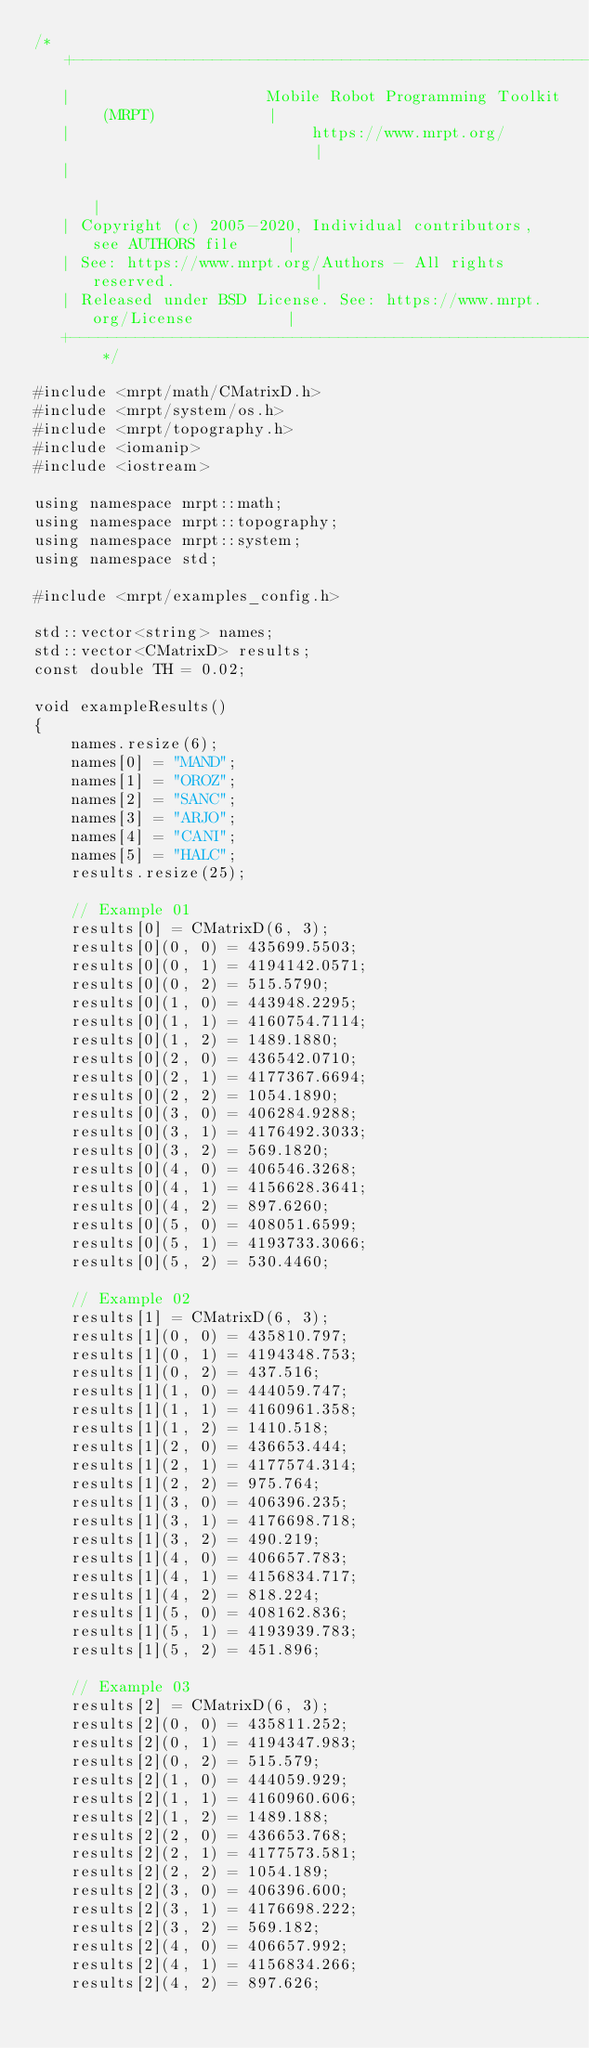<code> <loc_0><loc_0><loc_500><loc_500><_C++_>/* +------------------------------------------------------------------------+
   |                     Mobile Robot Programming Toolkit (MRPT)            |
   |                          https://www.mrpt.org/                         |
   |                                                                        |
   | Copyright (c) 2005-2020, Individual contributors, see AUTHORS file     |
   | See: https://www.mrpt.org/Authors - All rights reserved.               |
   | Released under BSD License. See: https://www.mrpt.org/License          |
   +------------------------------------------------------------------------+ */

#include <mrpt/math/CMatrixD.h>
#include <mrpt/system/os.h>
#include <mrpt/topography.h>
#include <iomanip>
#include <iostream>

using namespace mrpt::math;
using namespace mrpt::topography;
using namespace mrpt::system;
using namespace std;

#include <mrpt/examples_config.h>

std::vector<string> names;
std::vector<CMatrixD> results;
const double TH = 0.02;

void exampleResults()
{
	names.resize(6);
	names[0] = "MAND";
	names[1] = "OROZ";
	names[2] = "SANC";
	names[3] = "ARJO";
	names[4] = "CANI";
	names[5] = "HALC";
	results.resize(25);

	// Example 01
	results[0] = CMatrixD(6, 3);
	results[0](0, 0) = 435699.5503;
	results[0](0, 1) = 4194142.0571;
	results[0](0, 2) = 515.5790;
	results[0](1, 0) = 443948.2295;
	results[0](1, 1) = 4160754.7114;
	results[0](1, 2) = 1489.1880;
	results[0](2, 0) = 436542.0710;
	results[0](2, 1) = 4177367.6694;
	results[0](2, 2) = 1054.1890;
	results[0](3, 0) = 406284.9288;
	results[0](3, 1) = 4176492.3033;
	results[0](3, 2) = 569.1820;
	results[0](4, 0) = 406546.3268;
	results[0](4, 1) = 4156628.3641;
	results[0](4, 2) = 897.6260;
	results[0](5, 0) = 408051.6599;
	results[0](5, 1) = 4193733.3066;
	results[0](5, 2) = 530.4460;

	// Example 02
	results[1] = CMatrixD(6, 3);
	results[1](0, 0) = 435810.797;
	results[1](0, 1) = 4194348.753;
	results[1](0, 2) = 437.516;
	results[1](1, 0) = 444059.747;
	results[1](1, 1) = 4160961.358;
	results[1](1, 2) = 1410.518;
	results[1](2, 0) = 436653.444;
	results[1](2, 1) = 4177574.314;
	results[1](2, 2) = 975.764;
	results[1](3, 0) = 406396.235;
	results[1](3, 1) = 4176698.718;
	results[1](3, 2) = 490.219;
	results[1](4, 0) = 406657.783;
	results[1](4, 1) = 4156834.717;
	results[1](4, 2) = 818.224;
	results[1](5, 0) = 408162.836;
	results[1](5, 1) = 4193939.783;
	results[1](5, 2) = 451.896;

	// Example 03
	results[2] = CMatrixD(6, 3);
	results[2](0, 0) = 435811.252;
	results[2](0, 1) = 4194347.983;
	results[2](0, 2) = 515.579;
	results[2](1, 0) = 444059.929;
	results[2](1, 1) = 4160960.606;
	results[2](1, 2) = 1489.188;
	results[2](2, 0) = 436653.768;
	results[2](2, 1) = 4177573.581;
	results[2](2, 2) = 1054.189;
	results[2](3, 0) = 406396.600;
	results[2](3, 1) = 4176698.222;
	results[2](3, 2) = 569.182;
	results[2](4, 0) = 406657.992;
	results[2](4, 1) = 4156834.266;
	results[2](4, 2) = 897.626;</code> 